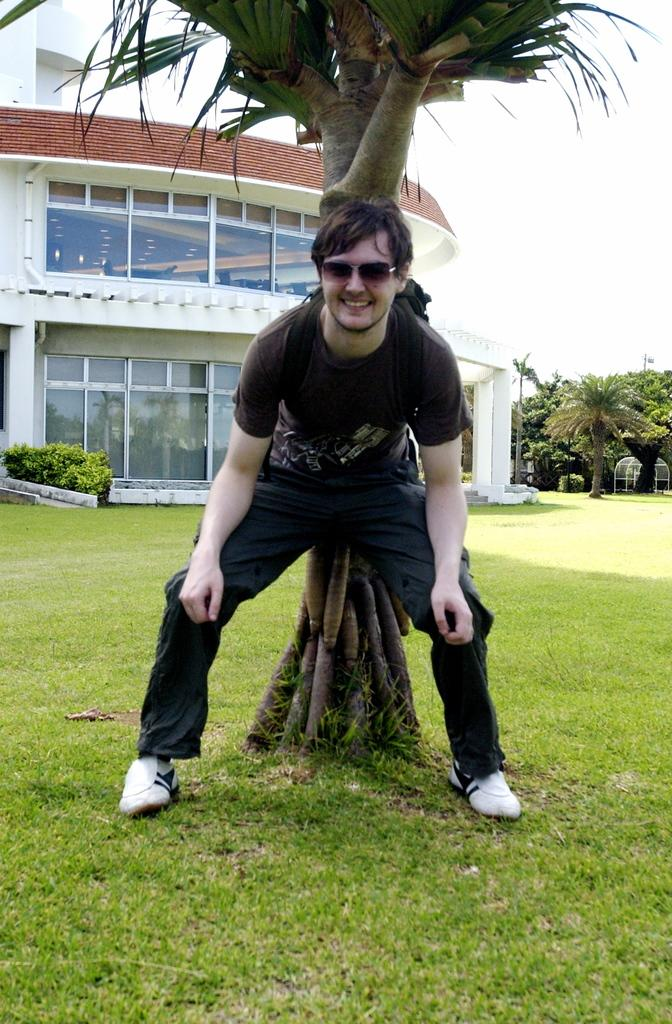What can be seen in the image? There is a person in the image, and they are wearing spectacles. What is the setting of the image? The ground is visible in the image, and there is grass on the ground. There are also trees and plants present. What part of the natural environment is visible in the image? The sky is visible in the image. Can you describe the unspecified object in the image? Unfortunately, the facts provided do not give any details about the unspecified object. Can you tell me how many rabbits are playing with the geese in the image? There are no rabbits or geese present in the image. What type of lace is used to decorate the person's clothing in the image? There is no mention of lace or any decorative elements on the person's clothing in the image. 